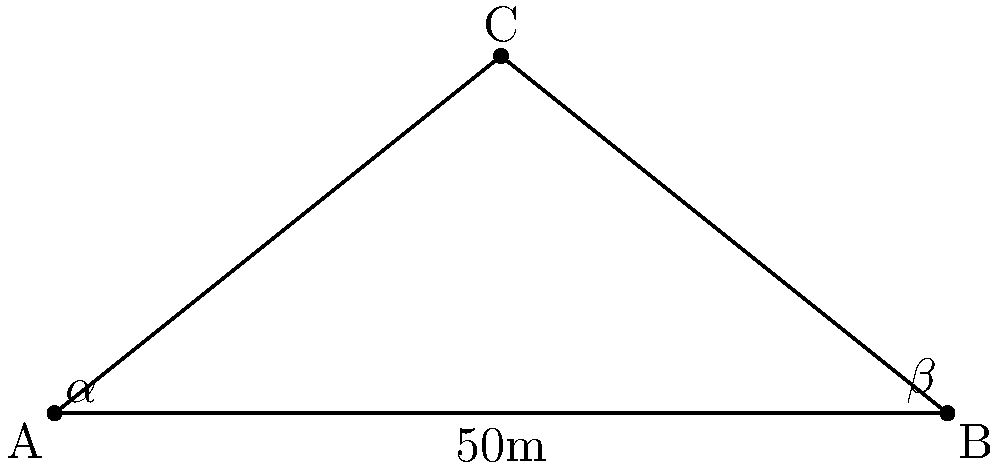As part of a digital transformation initiative, you're collaborating with a student on their drone research project. A drone is hovering above point C, and observations are made from points A and B, which are 50 meters apart on level ground. The angle of elevation of the drone from point A is $\alpha = 38.7°$, and from point B is $\beta = 51.3°$. Calculate the height of the drone above the ground. Let's approach this step-by-step:

1) We can use the tangent function to set up equations for the height (h) of the drone:

   From point A: $\tan(\alpha) = \frac{h}{x}$
   From point B: $\tan(\beta) = \frac{h}{50-x}$

   Where x is the distance from point A to the point directly below the drone.

2) We can equate these:

   $h = x \tan(\alpha) = (50-x) \tan(\beta)$

3) Solve for x:

   $x \tan(\alpha) = 50 \tan(\beta) - x \tan(\beta)$
   $x (\tan(\alpha) + \tan(\beta)) = 50 \tan(\beta)$
   $x = \frac{50 \tan(\beta)}{\tan(\alpha) + \tan(\beta)}$

4) Substitute the given values:

   $x = \frac{50 \tan(51.3°)}{\tan(38.7°) + \tan(51.3°)} \approx 27.78$ meters

5) Now we can find the height by using either of our original equations. Let's use the one from point A:

   $h = x \tan(\alpha) = 27.78 \tan(38.7°) \approx 21.96$ meters

Therefore, the height of the drone is approximately 21.96 meters.
Answer: $21.96$ meters 